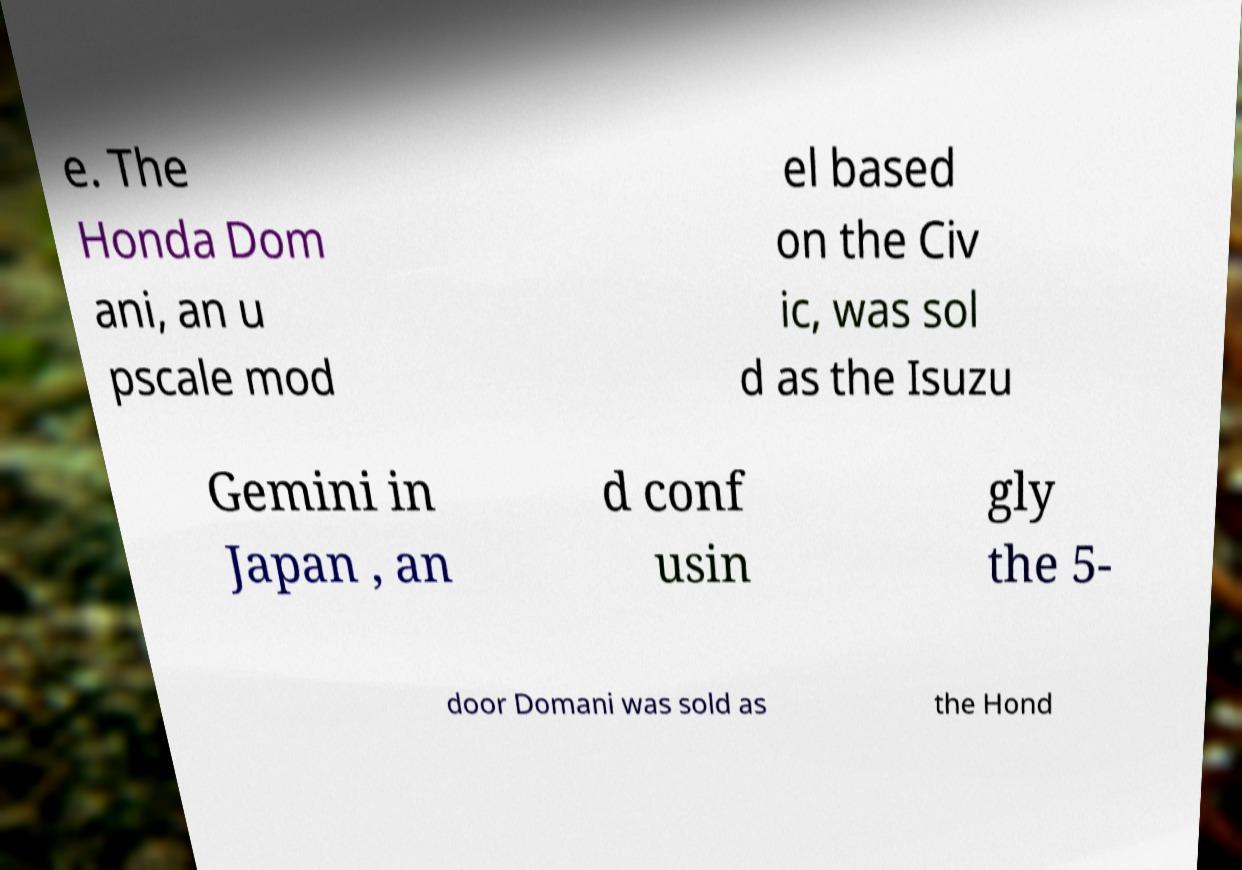Please read and relay the text visible in this image. What does it say? e. The Honda Dom ani, an u pscale mod el based on the Civ ic, was sol d as the Isuzu Gemini in Japan , an d conf usin gly the 5- door Domani was sold as the Hond 